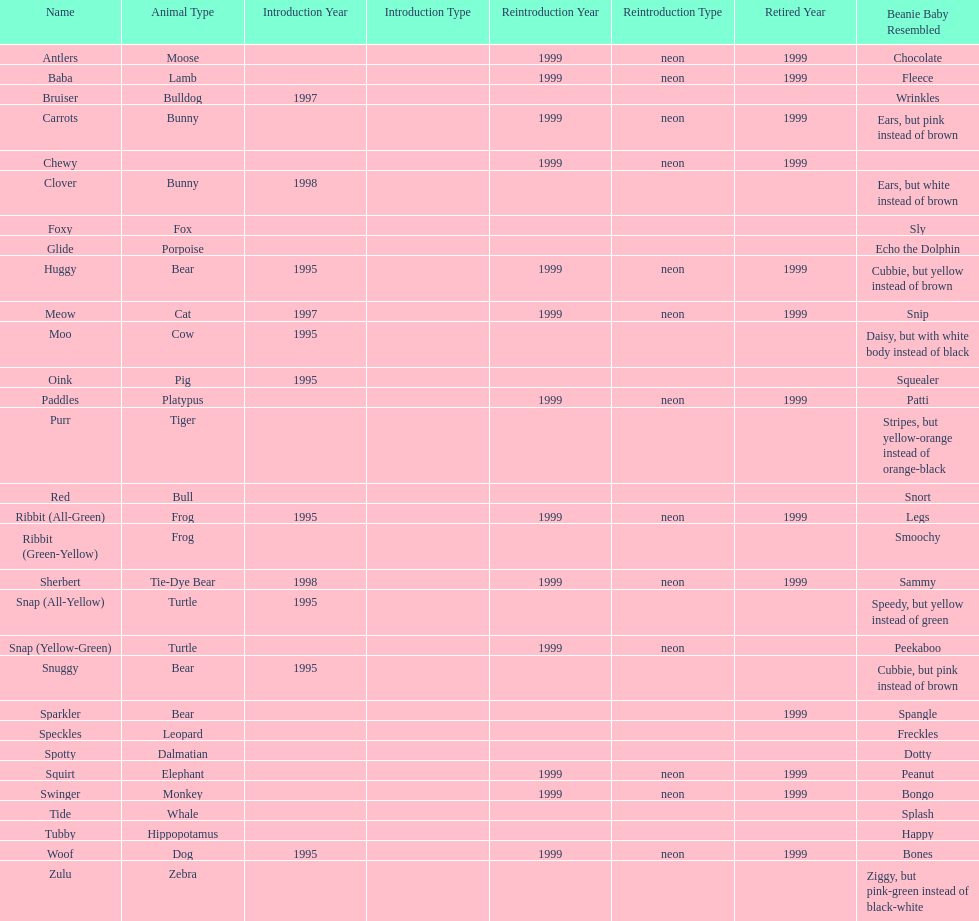Name the only pillow pal that is a dalmatian. Spotty. 